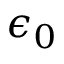Convert formula to latex. <formula><loc_0><loc_0><loc_500><loc_500>\epsilon _ { 0 }</formula> 